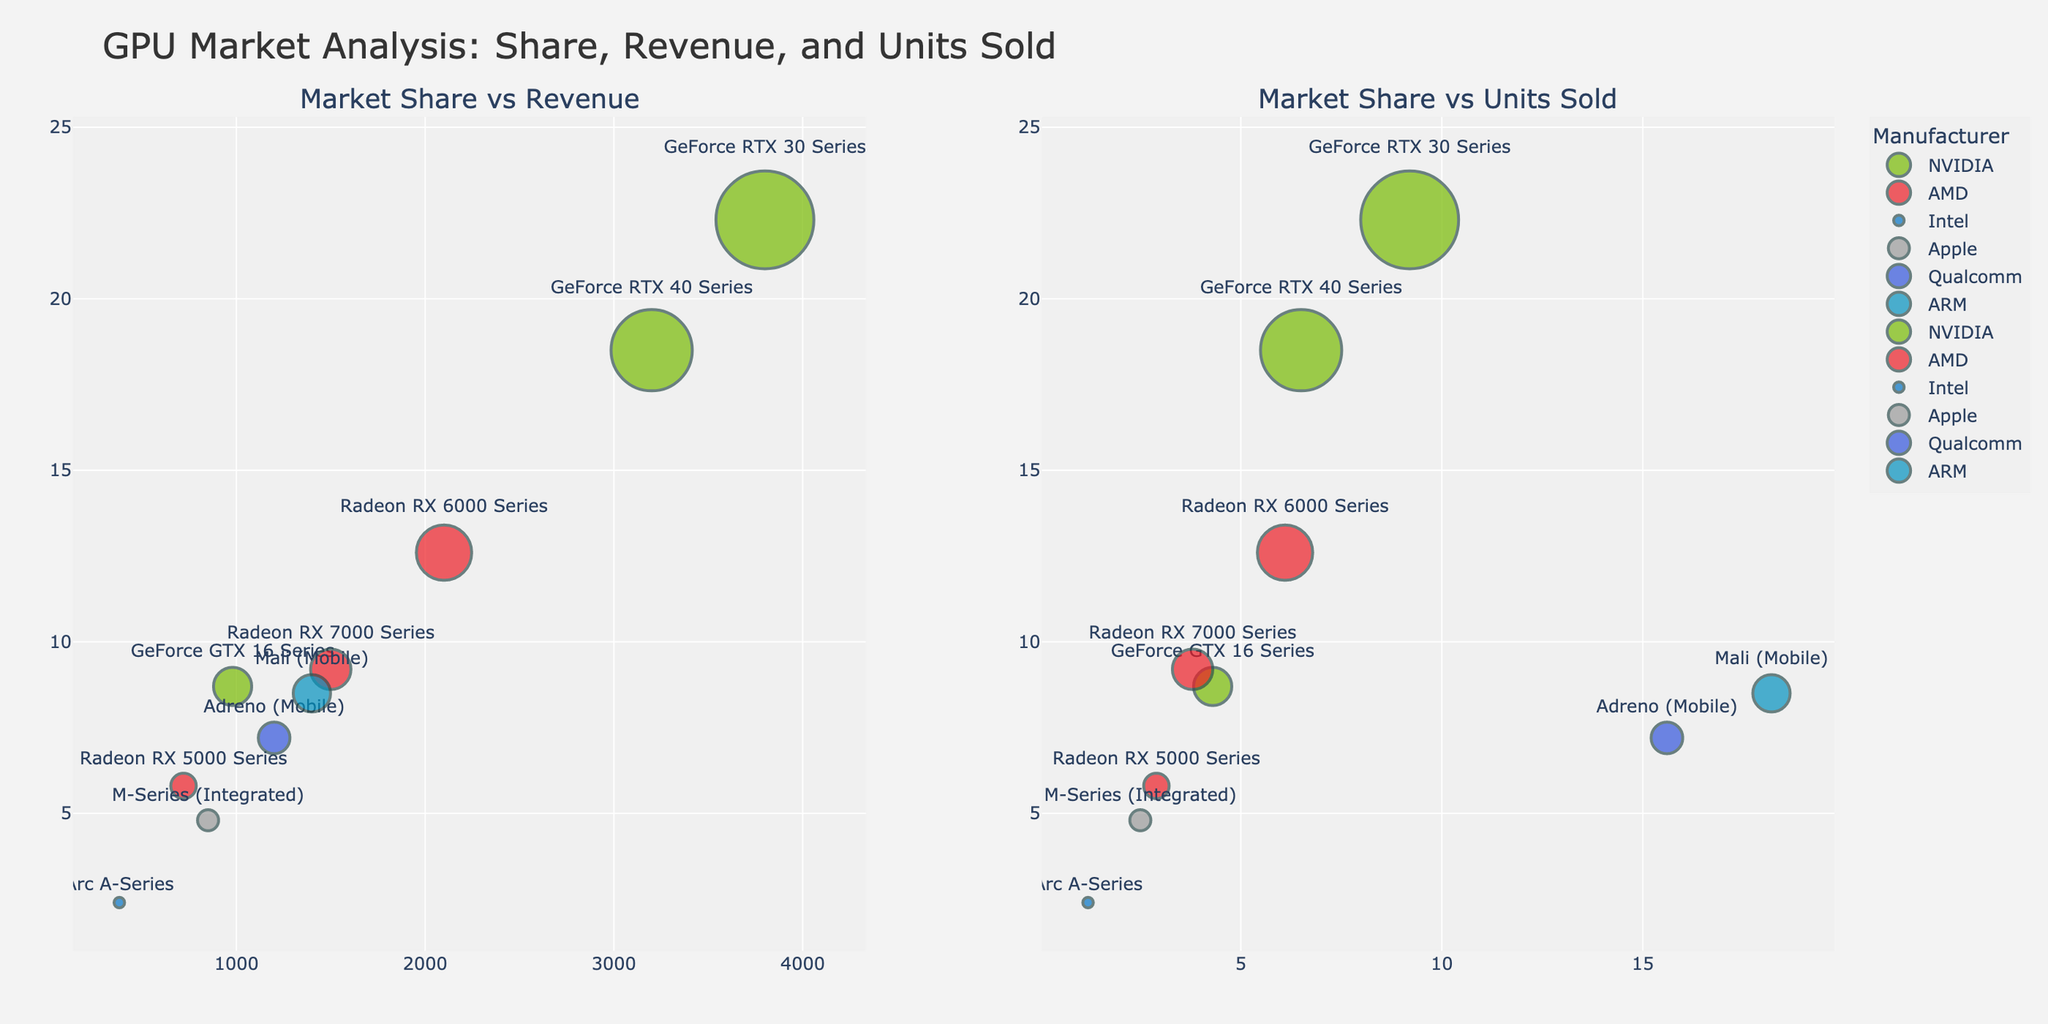What is the title of the figure? Look at the top center of the figure where the title is typically located. Read the full text presented.
Answer: GPU Market Analysis: Share, Revenue, and Units Sold Which manufacturer has the highest market share? On both subplots, look at the y-axis which represents "Market Share." Identify the tallest bubble and its corresponding manufacturer.
Answer: NVIDIA What color represents Apple’s products in the figures? Identify Apple's products from the text labels and then look at the color of the corresponding bubbles.
Answer: Gray How many product lines are represented by AMD? Count the text labels associated with AMD across the bubbles in both subplots. Each label corresponds to a unique product line.
Answer: 3 Which product line has the largest bubble size in the Market Share vs Units Sold subplot? In the subplots, larger bubbles indicate a higher "Market Share." Locate the subplot titled "Market Share vs Units Sold" and find the largest bubble.
Answer: ARM Mali (Mobile) How much revenue does Qualcomm generate compared to Apple? In the "Market Share vs Revenue" subplot, look at the x-values of Qualcomm and Apple bubbles which represent "Revenue (Millions USD)." Subtract Apple's revenue from Qualcomm's.
Answer: 1200 - 850 = 350 million USD Which manufacturer’s product line has the smallest market share? Check for the smallest y-value (Market Share %) among all bubbles in either subplot. Identify the corresponding manufacturer's product line.
Answer: Intel Arc A-Series What is the total market share of NVIDIA products? Add up the market share percentages for all NVIDIA product lines from both subplots.
Answer: 18.5 + 22.3 + 8.7 = 49.5% Which product line has the highest revenue per unit sold? For each product line, calculate the ratio of "Revenue (Millions USD)" to "Units Sold (Millions)" from the "Market Share vs Units Sold" subplot. Identify the product line with the highest ratio.
Answer: NVIDIA GeForce RTX 40 Series In which subplot do NVIDIA products generally appear on the right-most side? Look at both subplots to determine where NVIDIA bubbles (green) have the highest x-values, representing "Revenue" or "Units Sold."
Answer: Market Share vs Revenue 